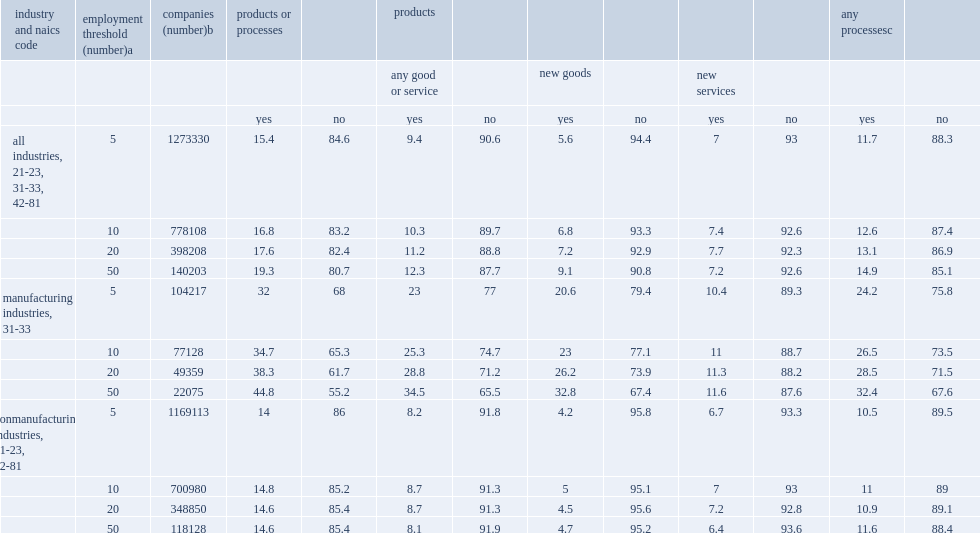Using the 10 employee threshold with the 2014 brdis data would increase the u.s. innovation rates for the total of all industries, how many percent for product or process innovations? 16.8. Using the 10 employee threshold with the 2014 brdis data would increase the u.s. innovation rates for the total of all industries, how many percent for product innovations? 10.3. Using the 10 employee threshold with the 2014 brdis data would increase the u.s. innovation rates for the total of all industries, how many percent for process innovations? 12.6. How many employees in manufacturing companies had higher innovation rates,20 or more or 5 employees? 20.0. What was the rates for manufacturing companies with 50 or more employees? 44.8. Among nonmanufacturing companies,what was the product or process innovation rate for companies with over 5 employees? 14.8. Among nonmanufacturing companies, what was the product or process innovation rate for companies with over 50 employees? 14.6. 